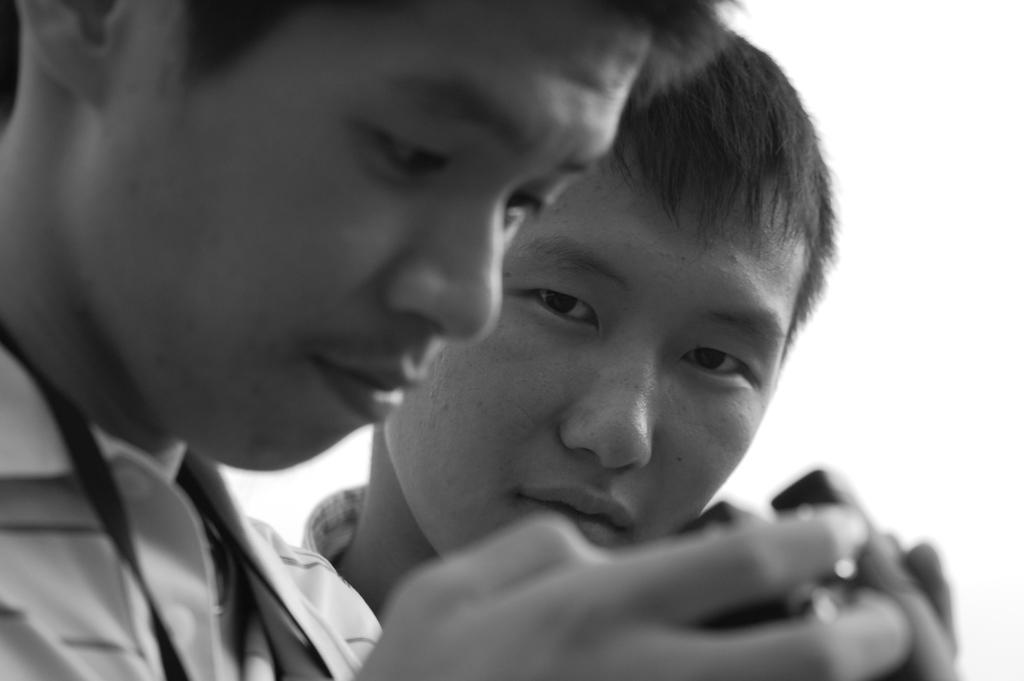What is the color scheme of the image? The image is black and white. Where is the first boy located in the image? The first boy is on the left side of the image, looking at the camera. What is the second boy doing in the image? The second boy is beside the first boy, looking to the side. Can you tell me how many baskets the boys are holding in the image? There are no baskets visible in the image; the boys are not holding any objects. What type of muscle is the father flexing in the image? There is no father or muscle flexing present in the image; it only features the two boys. 